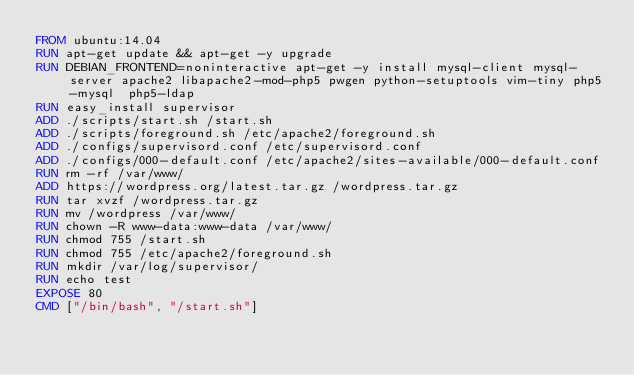Convert code to text. <code><loc_0><loc_0><loc_500><loc_500><_Dockerfile_>FROM ubuntu:14.04
RUN apt-get update && apt-get -y upgrade
RUN DEBIAN_FRONTEND=noninteractive apt-get -y install mysql-client mysql-server apache2 libapache2-mod-php5 pwgen python-setuptools vim-tiny php5-mysql  php5-ldap
RUN easy_install supervisor
ADD ./scripts/start.sh /start.sh
ADD ./scripts/foreground.sh /etc/apache2/foreground.sh
ADD ./configs/supervisord.conf /etc/supervisord.conf
ADD ./configs/000-default.conf /etc/apache2/sites-available/000-default.conf
RUN rm -rf /var/www/
ADD https://wordpress.org/latest.tar.gz /wordpress.tar.gz
RUN tar xvzf /wordpress.tar.gz 
RUN mv /wordpress /var/www/
RUN chown -R www-data:www-data /var/www/
RUN chmod 755 /start.sh
RUN chmod 755 /etc/apache2/foreground.sh
RUN mkdir /var/log/supervisor/
RUN echo test
EXPOSE 80
CMD ["/bin/bash", "/start.sh"]
</code> 